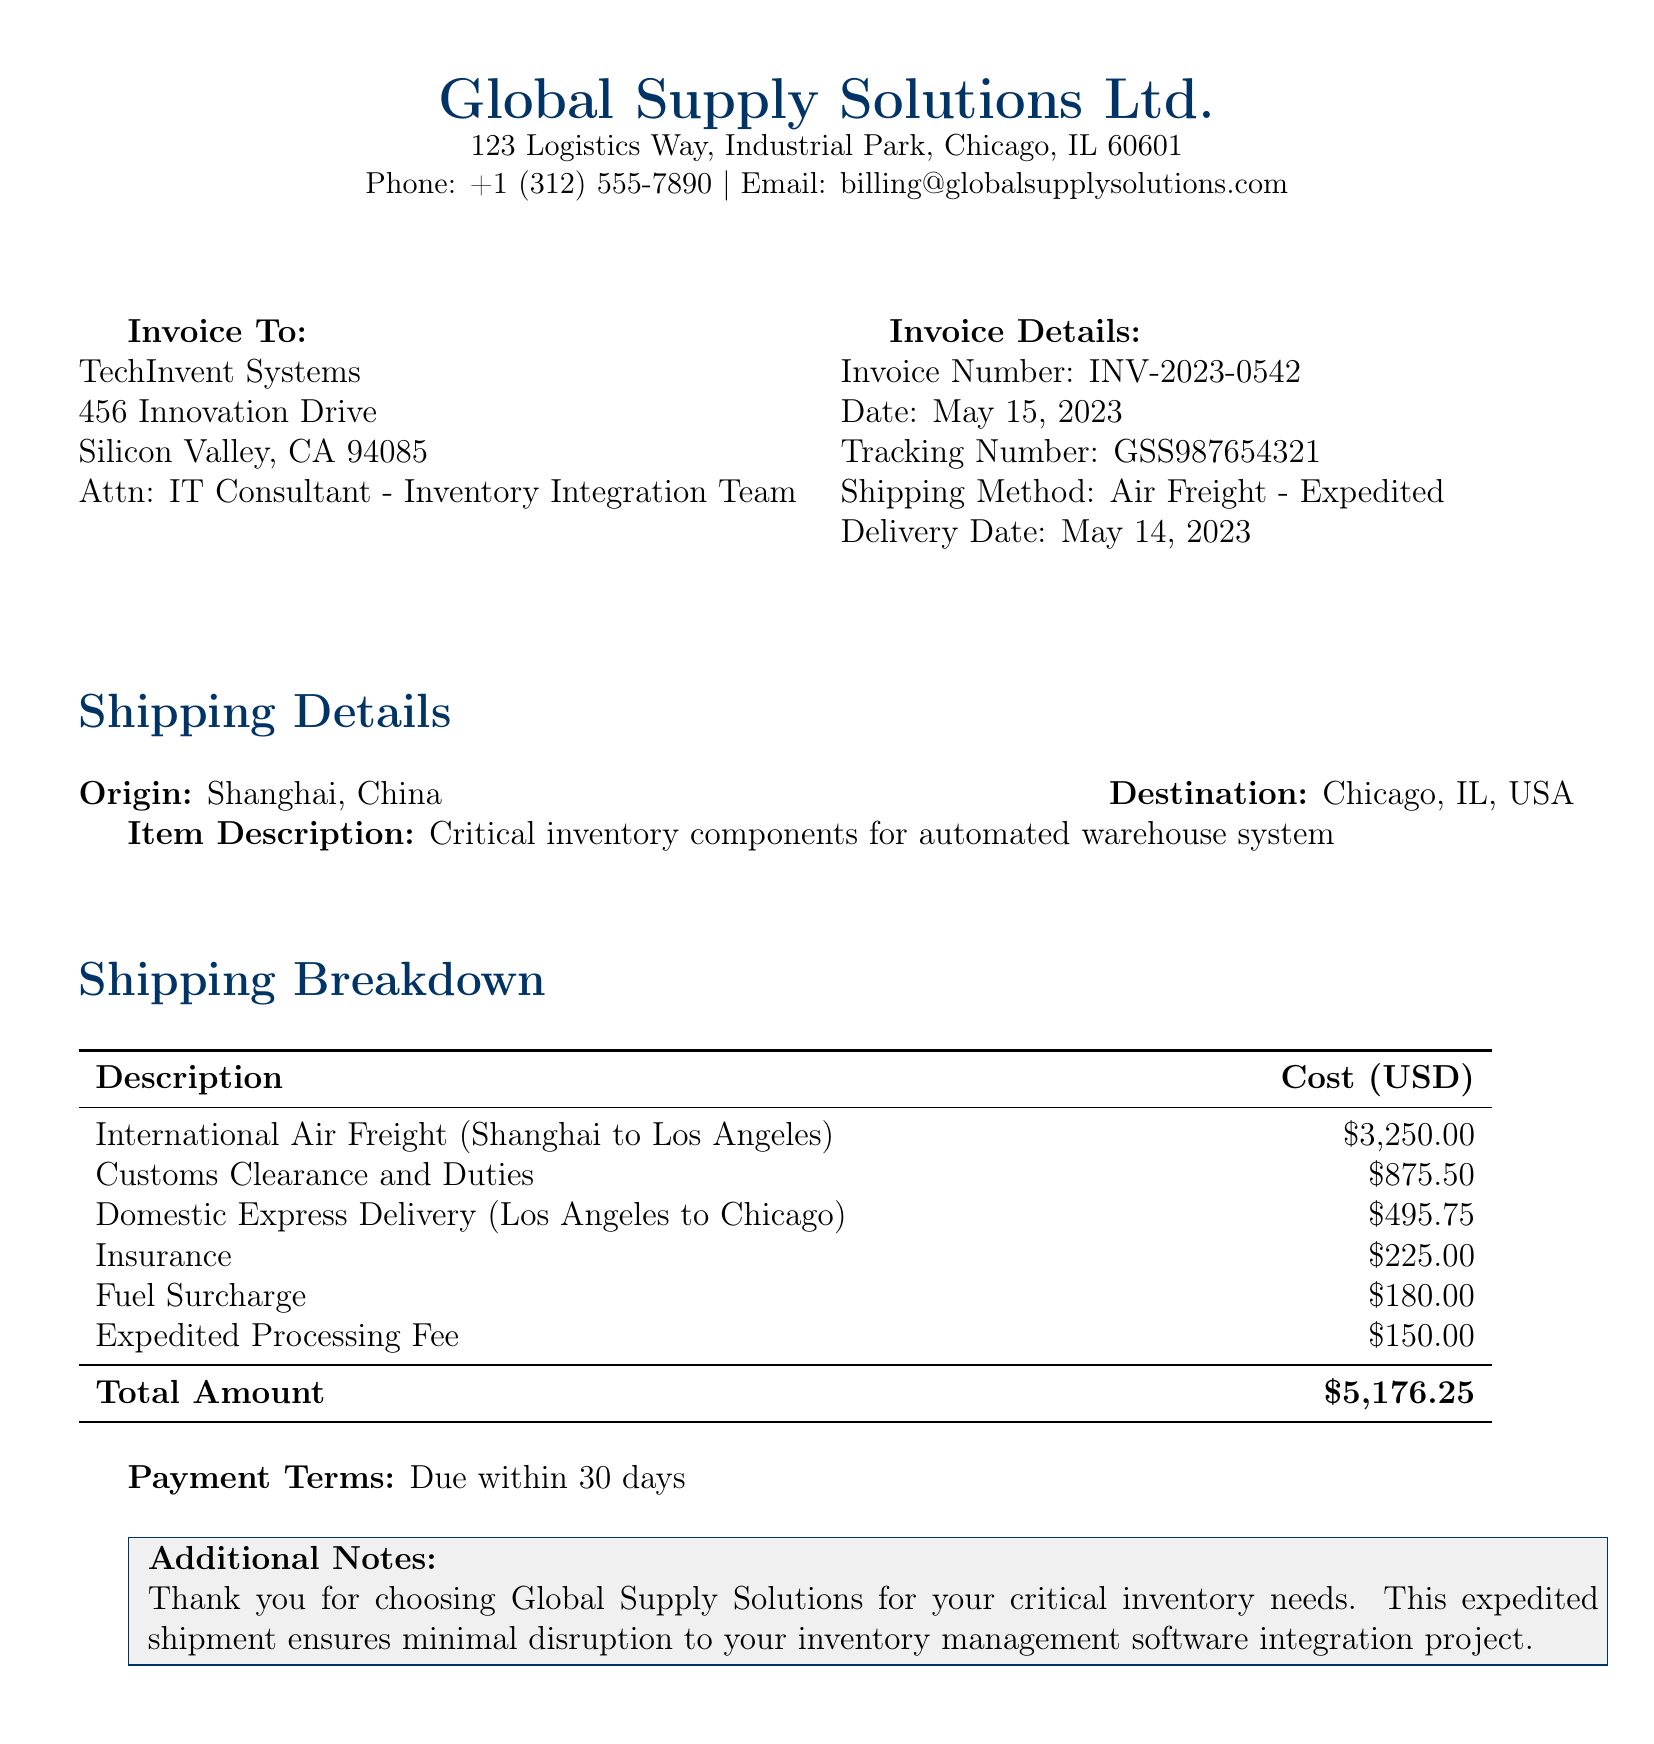What is the invoice number? The invoice number is specified in the invoice details section.
Answer: INV-2023-0542 What is the shipping method used? The shipping method is mentioned in the invoice details section.
Answer: Air Freight - Expedited What is the total amount due? The total amount is found in the shipping breakdown at the end of the table.
Answer: $5,176.25 What is the delivery date of the shipment? The delivery date is listed in the invoice details section.
Answer: May 14, 2023 How much was charged for Customs Clearance and Duties? The amount for Customs Clearance and Duties is specified in the shipping breakdown.
Answer: $875.50 What is the origin of the shipment? The origin is stated in the shipping details section.
Answer: Shanghai, China What is the cost of International Air Freight? The cost is provided in the shipping breakdown table.
Answer: $3,250.00 What is the payment term for this invoice? The payment term is outlined in the invoice details.
Answer: Due within 30 days What additional note is included in the document? The additional note expresses thanks for choosing the service and ensures minimal disruption.
Answer: Thank you for choosing Global Supply Solutions for your critical inventory needs. This expedited shipment ensures minimal disruption to your inventory management software integration project 